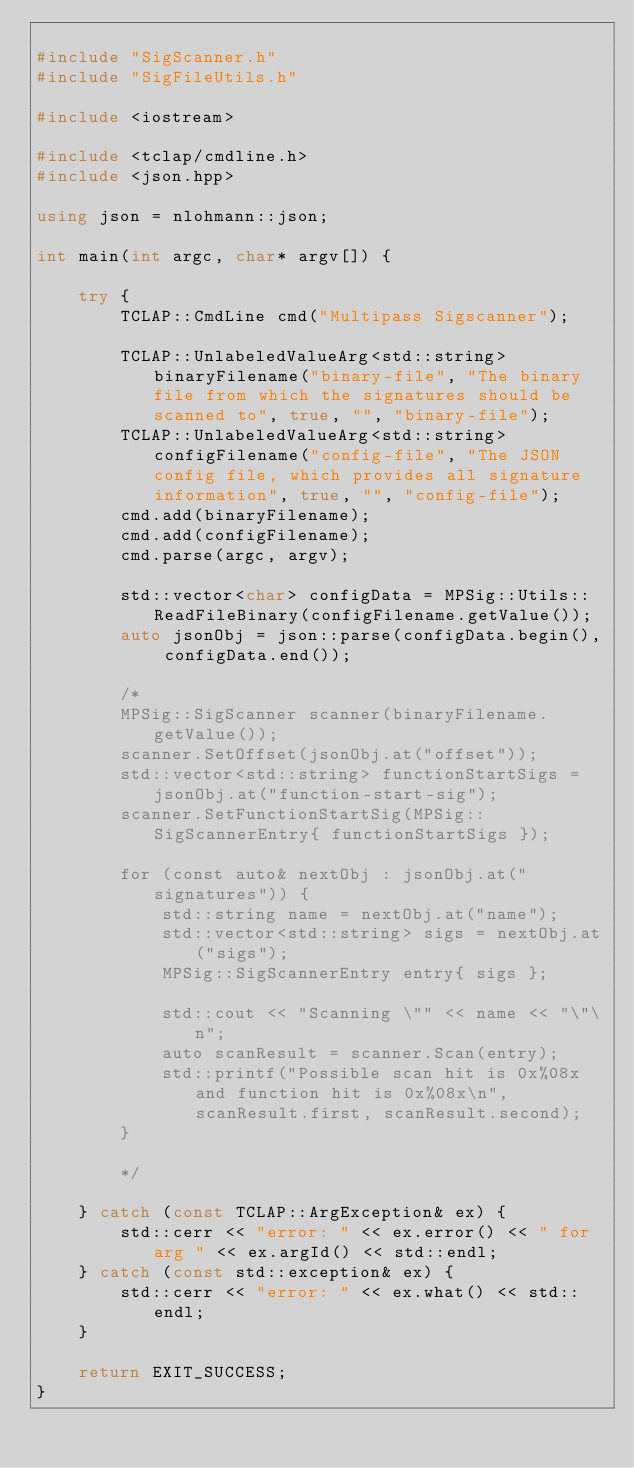Convert code to text. <code><loc_0><loc_0><loc_500><loc_500><_C++_>
#include "SigScanner.h"
#include "SigFileUtils.h"

#include <iostream>

#include <tclap/cmdline.h>
#include <json.hpp>

using json = nlohmann::json;

int main(int argc, char* argv[]) {

    try {
        TCLAP::CmdLine cmd("Multipass Sigscanner");

        TCLAP::UnlabeledValueArg<std::string> binaryFilename("binary-file", "The binary file from which the signatures should be scanned to", true, "", "binary-file");
        TCLAP::UnlabeledValueArg<std::string> configFilename("config-file", "The JSON config file, which provides all signature information", true, "", "config-file");
        cmd.add(binaryFilename);
        cmd.add(configFilename);
        cmd.parse(argc, argv);

        std::vector<char> configData = MPSig::Utils::ReadFileBinary(configFilename.getValue());
        auto jsonObj = json::parse(configData.begin(), configData.end());
        
        /*
        MPSig::SigScanner scanner(binaryFilename.getValue());
        scanner.SetOffset(jsonObj.at("offset"));
        std::vector<std::string> functionStartSigs = jsonObj.at("function-start-sig");
        scanner.SetFunctionStartSig(MPSig::SigScannerEntry{ functionStartSigs });

        for (const auto& nextObj : jsonObj.at("signatures")) {
            std::string name = nextObj.at("name");
            std::vector<std::string> sigs = nextObj.at("sigs");
            MPSig::SigScannerEntry entry{ sigs };
            
            std::cout << "Scanning \"" << name << "\"\n";
            auto scanResult = scanner.Scan(entry);
            std::printf("Possible scan hit is 0x%08x and function hit is 0x%08x\n", scanResult.first, scanResult.second);
        }

        */

    } catch (const TCLAP::ArgException& ex) {
        std::cerr << "error: " << ex.error() << " for arg " << ex.argId() << std::endl;
    } catch (const std::exception& ex) {
        std::cerr << "error: " << ex.what() << std::endl;
    }

    return EXIT_SUCCESS;
}
</code> 